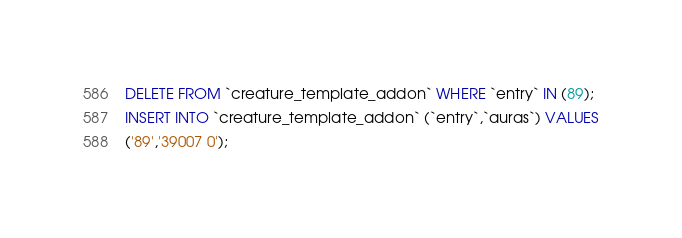<code> <loc_0><loc_0><loc_500><loc_500><_SQL_>DELETE FROM `creature_template_addon` WHERE `entry` IN (89);
INSERT INTO `creature_template_addon` (`entry`,`auras`) VALUES
('89','39007 0');</code> 